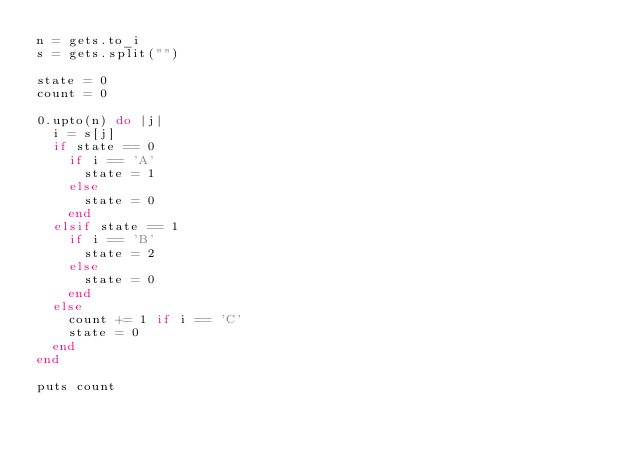Convert code to text. <code><loc_0><loc_0><loc_500><loc_500><_Ruby_>n = gets.to_i
s = gets.split("")

state = 0
count = 0

0.upto(n) do |j|
  i = s[j]
  if state == 0
    if i == 'A'
      state = 1
    else
      state = 0
    end
  elsif state == 1
    if i == 'B'
      state = 2
    else
      state = 0
    end
  else
    count += 1 if i == 'C'
    state = 0
  end
end
  
puts count</code> 